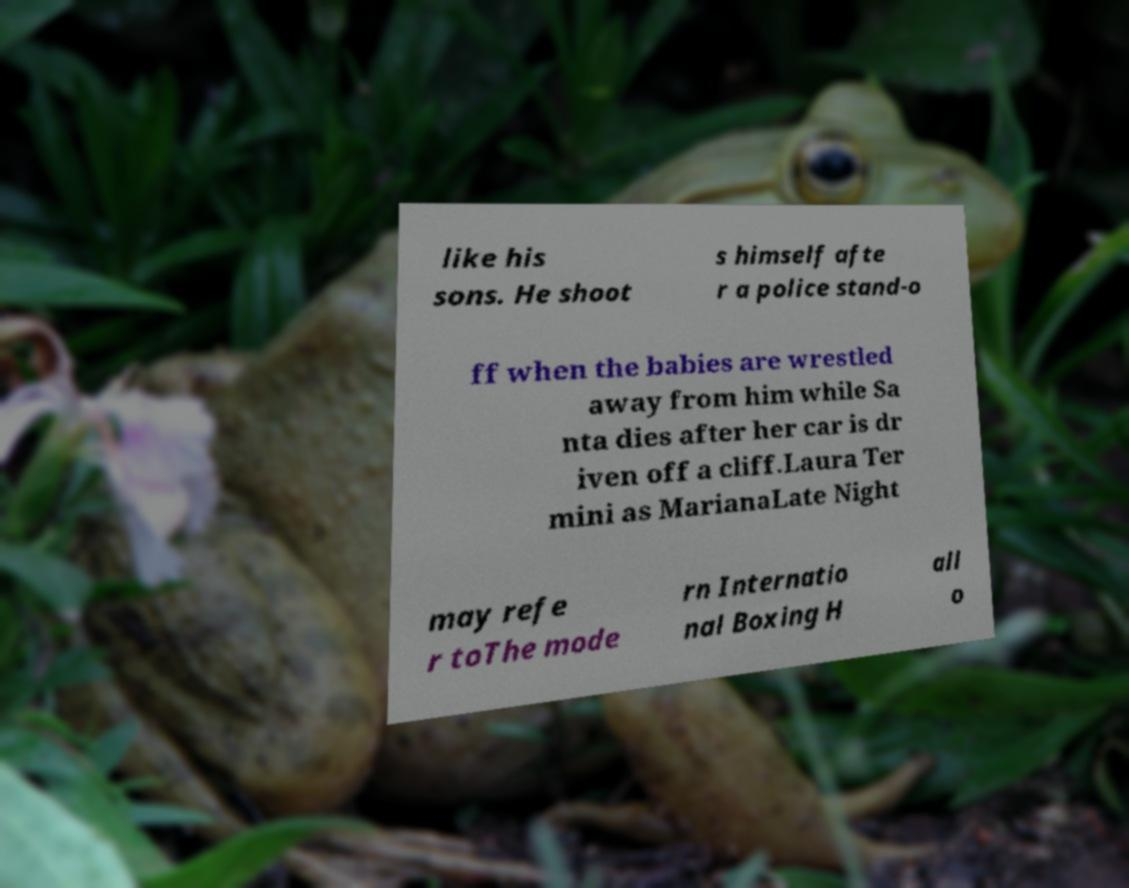Can you accurately transcribe the text from the provided image for me? like his sons. He shoot s himself afte r a police stand-o ff when the babies are wrestled away from him while Sa nta dies after her car is dr iven off a cliff.Laura Ter mini as MarianaLate Night may refe r toThe mode rn Internatio nal Boxing H all o 